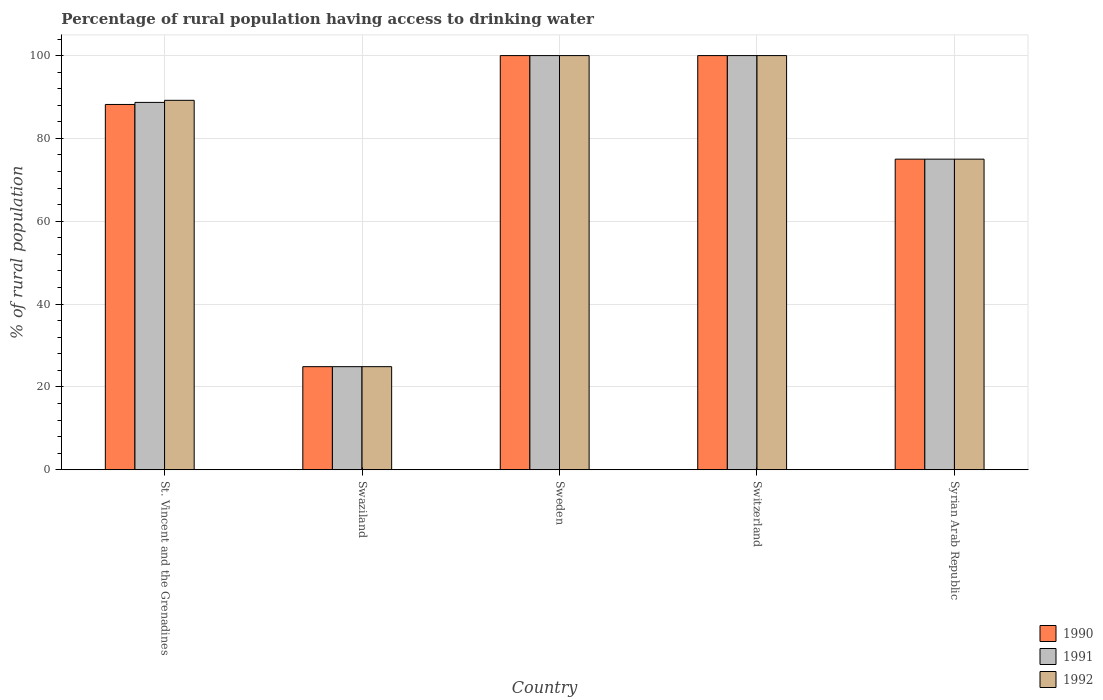Are the number of bars per tick equal to the number of legend labels?
Provide a succinct answer. Yes. Are the number of bars on each tick of the X-axis equal?
Your response must be concise. Yes. How many bars are there on the 3rd tick from the right?
Ensure brevity in your answer.  3. What is the label of the 3rd group of bars from the left?
Offer a terse response. Sweden. In how many cases, is the number of bars for a given country not equal to the number of legend labels?
Ensure brevity in your answer.  0. Across all countries, what is the minimum percentage of rural population having access to drinking water in 1990?
Offer a very short reply. 24.9. In which country was the percentage of rural population having access to drinking water in 1990 minimum?
Your answer should be very brief. Swaziland. What is the total percentage of rural population having access to drinking water in 1990 in the graph?
Keep it short and to the point. 388.1. What is the average percentage of rural population having access to drinking water in 1992 per country?
Provide a short and direct response. 77.82. What is the ratio of the percentage of rural population having access to drinking water in 1991 in Swaziland to that in Switzerland?
Offer a terse response. 0.25. What is the difference between the highest and the second highest percentage of rural population having access to drinking water in 1991?
Ensure brevity in your answer.  -11.3. What is the difference between the highest and the lowest percentage of rural population having access to drinking water in 1991?
Your answer should be compact. 75.1. In how many countries, is the percentage of rural population having access to drinking water in 1991 greater than the average percentage of rural population having access to drinking water in 1991 taken over all countries?
Offer a terse response. 3. What does the 3rd bar from the left in Switzerland represents?
Ensure brevity in your answer.  1992. How many bars are there?
Provide a succinct answer. 15. Are all the bars in the graph horizontal?
Your answer should be very brief. No. How many countries are there in the graph?
Keep it short and to the point. 5. Does the graph contain any zero values?
Offer a very short reply. No. Does the graph contain grids?
Make the answer very short. Yes. Where does the legend appear in the graph?
Keep it short and to the point. Bottom right. How many legend labels are there?
Provide a succinct answer. 3. What is the title of the graph?
Keep it short and to the point. Percentage of rural population having access to drinking water. Does "1967" appear as one of the legend labels in the graph?
Your answer should be very brief. No. What is the label or title of the Y-axis?
Give a very brief answer. % of rural population. What is the % of rural population of 1990 in St. Vincent and the Grenadines?
Offer a terse response. 88.2. What is the % of rural population of 1991 in St. Vincent and the Grenadines?
Offer a terse response. 88.7. What is the % of rural population of 1992 in St. Vincent and the Grenadines?
Your answer should be very brief. 89.2. What is the % of rural population in 1990 in Swaziland?
Provide a succinct answer. 24.9. What is the % of rural population of 1991 in Swaziland?
Provide a succinct answer. 24.9. What is the % of rural population of 1992 in Swaziland?
Provide a short and direct response. 24.9. What is the % of rural population in 1990 in Sweden?
Your response must be concise. 100. What is the % of rural population in 1990 in Switzerland?
Make the answer very short. 100. What is the % of rural population of 1990 in Syrian Arab Republic?
Your response must be concise. 75. What is the % of rural population of 1991 in Syrian Arab Republic?
Offer a very short reply. 75. What is the % of rural population in 1992 in Syrian Arab Republic?
Make the answer very short. 75. Across all countries, what is the maximum % of rural population in 1991?
Provide a succinct answer. 100. Across all countries, what is the maximum % of rural population of 1992?
Provide a short and direct response. 100. Across all countries, what is the minimum % of rural population in 1990?
Provide a short and direct response. 24.9. Across all countries, what is the minimum % of rural population of 1991?
Offer a terse response. 24.9. Across all countries, what is the minimum % of rural population in 1992?
Your answer should be compact. 24.9. What is the total % of rural population of 1990 in the graph?
Offer a terse response. 388.1. What is the total % of rural population in 1991 in the graph?
Give a very brief answer. 388.6. What is the total % of rural population of 1992 in the graph?
Make the answer very short. 389.1. What is the difference between the % of rural population of 1990 in St. Vincent and the Grenadines and that in Swaziland?
Make the answer very short. 63.3. What is the difference between the % of rural population of 1991 in St. Vincent and the Grenadines and that in Swaziland?
Give a very brief answer. 63.8. What is the difference between the % of rural population of 1992 in St. Vincent and the Grenadines and that in Swaziland?
Make the answer very short. 64.3. What is the difference between the % of rural population of 1990 in St. Vincent and the Grenadines and that in Sweden?
Provide a short and direct response. -11.8. What is the difference between the % of rural population of 1990 in St. Vincent and the Grenadines and that in Switzerland?
Offer a very short reply. -11.8. What is the difference between the % of rural population of 1992 in St. Vincent and the Grenadines and that in Switzerland?
Make the answer very short. -10.8. What is the difference between the % of rural population in 1990 in Swaziland and that in Sweden?
Give a very brief answer. -75.1. What is the difference between the % of rural population of 1991 in Swaziland and that in Sweden?
Offer a terse response. -75.1. What is the difference between the % of rural population of 1992 in Swaziland and that in Sweden?
Your response must be concise. -75.1. What is the difference between the % of rural population of 1990 in Swaziland and that in Switzerland?
Your answer should be very brief. -75.1. What is the difference between the % of rural population of 1991 in Swaziland and that in Switzerland?
Offer a terse response. -75.1. What is the difference between the % of rural population in 1992 in Swaziland and that in Switzerland?
Offer a terse response. -75.1. What is the difference between the % of rural population in 1990 in Swaziland and that in Syrian Arab Republic?
Provide a short and direct response. -50.1. What is the difference between the % of rural population in 1991 in Swaziland and that in Syrian Arab Republic?
Provide a succinct answer. -50.1. What is the difference between the % of rural population in 1992 in Swaziland and that in Syrian Arab Republic?
Your response must be concise. -50.1. What is the difference between the % of rural population of 1990 in Sweden and that in Switzerland?
Ensure brevity in your answer.  0. What is the difference between the % of rural population in 1991 in Sweden and that in Switzerland?
Make the answer very short. 0. What is the difference between the % of rural population of 1992 in Sweden and that in Switzerland?
Provide a short and direct response. 0. What is the difference between the % of rural population in 1990 in Sweden and that in Syrian Arab Republic?
Provide a succinct answer. 25. What is the difference between the % of rural population of 1992 in Sweden and that in Syrian Arab Republic?
Make the answer very short. 25. What is the difference between the % of rural population of 1990 in Switzerland and that in Syrian Arab Republic?
Your answer should be very brief. 25. What is the difference between the % of rural population of 1991 in Switzerland and that in Syrian Arab Republic?
Keep it short and to the point. 25. What is the difference between the % of rural population of 1992 in Switzerland and that in Syrian Arab Republic?
Ensure brevity in your answer.  25. What is the difference between the % of rural population of 1990 in St. Vincent and the Grenadines and the % of rural population of 1991 in Swaziland?
Keep it short and to the point. 63.3. What is the difference between the % of rural population of 1990 in St. Vincent and the Grenadines and the % of rural population of 1992 in Swaziland?
Offer a very short reply. 63.3. What is the difference between the % of rural population in 1991 in St. Vincent and the Grenadines and the % of rural population in 1992 in Swaziland?
Give a very brief answer. 63.8. What is the difference between the % of rural population in 1990 in St. Vincent and the Grenadines and the % of rural population in 1992 in Sweden?
Give a very brief answer. -11.8. What is the difference between the % of rural population of 1990 in St. Vincent and the Grenadines and the % of rural population of 1991 in Switzerland?
Ensure brevity in your answer.  -11.8. What is the difference between the % of rural population of 1991 in St. Vincent and the Grenadines and the % of rural population of 1992 in Switzerland?
Keep it short and to the point. -11.3. What is the difference between the % of rural population in 1990 in St. Vincent and the Grenadines and the % of rural population in 1991 in Syrian Arab Republic?
Your answer should be very brief. 13.2. What is the difference between the % of rural population in 1991 in St. Vincent and the Grenadines and the % of rural population in 1992 in Syrian Arab Republic?
Your answer should be very brief. 13.7. What is the difference between the % of rural population in 1990 in Swaziland and the % of rural population in 1991 in Sweden?
Your answer should be very brief. -75.1. What is the difference between the % of rural population in 1990 in Swaziland and the % of rural population in 1992 in Sweden?
Offer a very short reply. -75.1. What is the difference between the % of rural population in 1991 in Swaziland and the % of rural population in 1992 in Sweden?
Make the answer very short. -75.1. What is the difference between the % of rural population in 1990 in Swaziland and the % of rural population in 1991 in Switzerland?
Keep it short and to the point. -75.1. What is the difference between the % of rural population of 1990 in Swaziland and the % of rural population of 1992 in Switzerland?
Your response must be concise. -75.1. What is the difference between the % of rural population in 1991 in Swaziland and the % of rural population in 1992 in Switzerland?
Provide a short and direct response. -75.1. What is the difference between the % of rural population of 1990 in Swaziland and the % of rural population of 1991 in Syrian Arab Republic?
Offer a very short reply. -50.1. What is the difference between the % of rural population in 1990 in Swaziland and the % of rural population in 1992 in Syrian Arab Republic?
Keep it short and to the point. -50.1. What is the difference between the % of rural population of 1991 in Swaziland and the % of rural population of 1992 in Syrian Arab Republic?
Keep it short and to the point. -50.1. What is the difference between the % of rural population of 1991 in Sweden and the % of rural population of 1992 in Switzerland?
Your answer should be compact. 0. What is the difference between the % of rural population in 1991 in Sweden and the % of rural population in 1992 in Syrian Arab Republic?
Make the answer very short. 25. What is the difference between the % of rural population of 1990 in Switzerland and the % of rural population of 1992 in Syrian Arab Republic?
Keep it short and to the point. 25. What is the difference between the % of rural population in 1991 in Switzerland and the % of rural population in 1992 in Syrian Arab Republic?
Your answer should be compact. 25. What is the average % of rural population of 1990 per country?
Your response must be concise. 77.62. What is the average % of rural population in 1991 per country?
Offer a terse response. 77.72. What is the average % of rural population in 1992 per country?
Ensure brevity in your answer.  77.82. What is the difference between the % of rural population in 1990 and % of rural population in 1992 in Swaziland?
Your answer should be very brief. 0. What is the difference between the % of rural population of 1990 and % of rural population of 1992 in Sweden?
Give a very brief answer. 0. What is the difference between the % of rural population in 1991 and % of rural population in 1992 in Sweden?
Give a very brief answer. 0. What is the difference between the % of rural population of 1990 and % of rural population of 1991 in Switzerland?
Provide a succinct answer. 0. What is the difference between the % of rural population of 1991 and % of rural population of 1992 in Switzerland?
Your response must be concise. 0. What is the ratio of the % of rural population in 1990 in St. Vincent and the Grenadines to that in Swaziland?
Your response must be concise. 3.54. What is the ratio of the % of rural population in 1991 in St. Vincent and the Grenadines to that in Swaziland?
Offer a terse response. 3.56. What is the ratio of the % of rural population of 1992 in St. Vincent and the Grenadines to that in Swaziland?
Ensure brevity in your answer.  3.58. What is the ratio of the % of rural population of 1990 in St. Vincent and the Grenadines to that in Sweden?
Your response must be concise. 0.88. What is the ratio of the % of rural population of 1991 in St. Vincent and the Grenadines to that in Sweden?
Your answer should be compact. 0.89. What is the ratio of the % of rural population of 1992 in St. Vincent and the Grenadines to that in Sweden?
Your answer should be very brief. 0.89. What is the ratio of the % of rural population of 1990 in St. Vincent and the Grenadines to that in Switzerland?
Make the answer very short. 0.88. What is the ratio of the % of rural population in 1991 in St. Vincent and the Grenadines to that in Switzerland?
Keep it short and to the point. 0.89. What is the ratio of the % of rural population in 1992 in St. Vincent and the Grenadines to that in Switzerland?
Offer a very short reply. 0.89. What is the ratio of the % of rural population of 1990 in St. Vincent and the Grenadines to that in Syrian Arab Republic?
Provide a short and direct response. 1.18. What is the ratio of the % of rural population of 1991 in St. Vincent and the Grenadines to that in Syrian Arab Republic?
Offer a terse response. 1.18. What is the ratio of the % of rural population of 1992 in St. Vincent and the Grenadines to that in Syrian Arab Republic?
Your answer should be compact. 1.19. What is the ratio of the % of rural population in 1990 in Swaziland to that in Sweden?
Make the answer very short. 0.25. What is the ratio of the % of rural population in 1991 in Swaziland to that in Sweden?
Your answer should be compact. 0.25. What is the ratio of the % of rural population of 1992 in Swaziland to that in Sweden?
Keep it short and to the point. 0.25. What is the ratio of the % of rural population of 1990 in Swaziland to that in Switzerland?
Your answer should be very brief. 0.25. What is the ratio of the % of rural population in 1991 in Swaziland to that in Switzerland?
Offer a terse response. 0.25. What is the ratio of the % of rural population of 1992 in Swaziland to that in Switzerland?
Your response must be concise. 0.25. What is the ratio of the % of rural population of 1990 in Swaziland to that in Syrian Arab Republic?
Your response must be concise. 0.33. What is the ratio of the % of rural population of 1991 in Swaziland to that in Syrian Arab Republic?
Offer a very short reply. 0.33. What is the ratio of the % of rural population in 1992 in Swaziland to that in Syrian Arab Republic?
Provide a succinct answer. 0.33. What is the ratio of the % of rural population in 1990 in Sweden to that in Switzerland?
Provide a succinct answer. 1. What is the ratio of the % of rural population of 1992 in Sweden to that in Switzerland?
Ensure brevity in your answer.  1. What is the ratio of the % of rural population of 1990 in Switzerland to that in Syrian Arab Republic?
Keep it short and to the point. 1.33. What is the ratio of the % of rural population of 1991 in Switzerland to that in Syrian Arab Republic?
Make the answer very short. 1.33. What is the ratio of the % of rural population in 1992 in Switzerland to that in Syrian Arab Republic?
Provide a succinct answer. 1.33. What is the difference between the highest and the second highest % of rural population in 1990?
Your response must be concise. 0. What is the difference between the highest and the second highest % of rural population in 1991?
Provide a succinct answer. 0. What is the difference between the highest and the lowest % of rural population of 1990?
Offer a very short reply. 75.1. What is the difference between the highest and the lowest % of rural population of 1991?
Give a very brief answer. 75.1. What is the difference between the highest and the lowest % of rural population of 1992?
Make the answer very short. 75.1. 